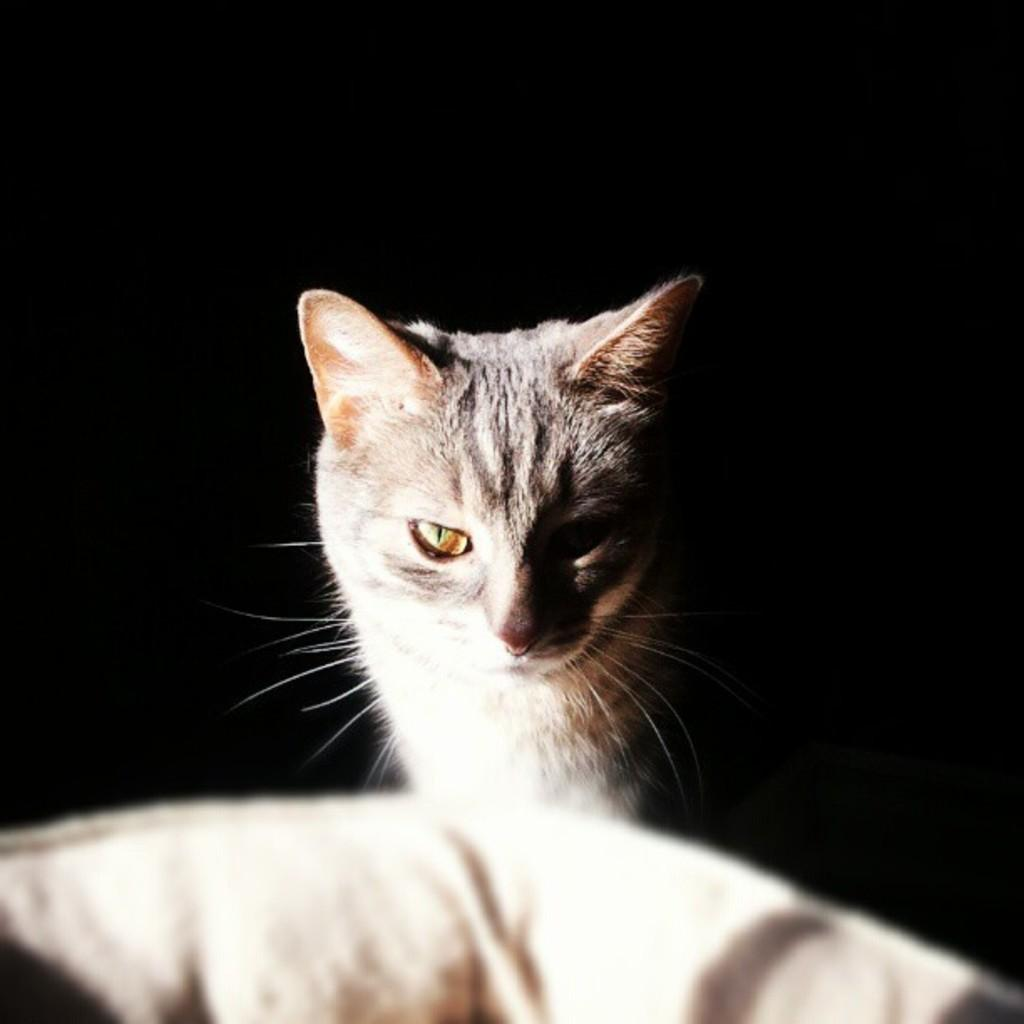What is the main subject in the foreground of the image? There is a cat in the foreground of the image. Can you describe the position of the cat in the foreground? The cat is in the middle of the foreground. What can be seen at the bottom of the image? There is an object at the bottom of the image. How would you describe the background of the image? The background of the image is dark. What type of language is the cat speaking in the image? Cats do not speak human languages, so there is no language spoken by the cat in the image. 